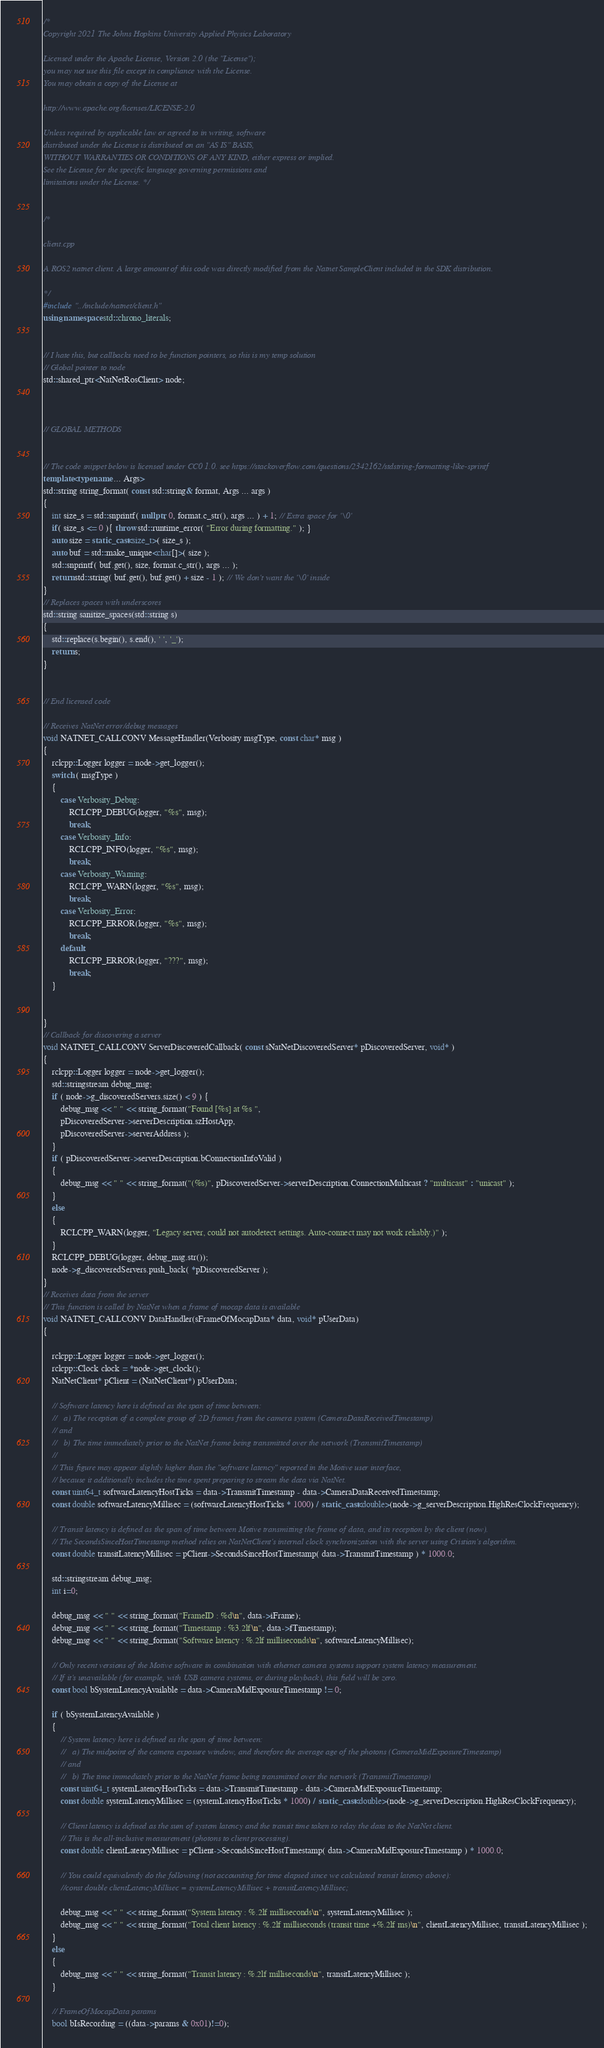Convert code to text. <code><loc_0><loc_0><loc_500><loc_500><_C++_>/* 
Copyright 2021 The Johns Hopkins University Applied Physics Laboratory

Licensed under the Apache License, Version 2.0 (the "License");
you may not use this file except in compliance with the License.
You may obtain a copy of the License at

http://www.apache.org/licenses/LICENSE-2.0

Unless required by applicable law or agreed to in writing, software
distributed under the License is distributed on an "AS IS" BASIS,
WITHOUT WARRANTIES OR CONDITIONS OF ANY KIND, either express or implied.
See the License for the specific language governing permissions and
limitations under the License. */


/*

client.cpp

A ROS2 natnet client. A large amount of this code was directly modified from the Natnet SampleClient included in the SDK distribution. 

*/
#include "../include/natnet/client.h"
using namespace std::chrono_literals;


// I hate this, but callbacks need to be function pointers, so this is my temp solution
// Global pointer to node
std::shared_ptr<NatNetRosClient> node;



// GLOBAL METHODS


// The code snippet below is licensed under CC0 1.0. see https://stackoverflow.com/questions/2342162/stdstring-formatting-like-sprintf
template<typename ... Args>
std::string string_format( const std::string& format, Args ... args )
{
    int size_s = std::snprintf( nullptr, 0, format.c_str(), args ... ) + 1; // Extra space for '\0'
    if( size_s <= 0 ){ throw std::runtime_error( "Error during formatting." ); }
    auto size = static_cast<size_t>( size_s );
    auto buf = std::make_unique<char[]>( size );
    std::snprintf( buf.get(), size, format.c_str(), args ... );
    return std::string( buf.get(), buf.get() + size - 1 ); // We don't want the '\0' inside
}
// Replaces spaces with underscores
std::string sanitize_spaces(std::string s)
{
    std::replace(s.begin(), s.end(), ' ', '_');
    return s;
}


// End licensed code

// Receives NatNet error/debug messages
void NATNET_CALLCONV MessageHandler(Verbosity msgType, const char* msg )
{
    rclcpp::Logger logger = node->get_logger();
    switch ( msgType )
    {
        case Verbosity_Debug:
            RCLCPP_DEBUG(logger, "%s", msg);
            break;
        case Verbosity_Info:
            RCLCPP_INFO(logger, "%s", msg);
            break;
        case Verbosity_Warning:
            RCLCPP_WARN(logger, "%s", msg);
            break;
        case Verbosity_Error:
            RCLCPP_ERROR(logger, "%s", msg);
            break;
        default:
            RCLCPP_ERROR(logger, "???", msg);
            break;
    }

    
}
// Callback for discovering a server
void NATNET_CALLCONV ServerDiscoveredCallback( const sNatNetDiscoveredServer* pDiscoveredServer, void* )
{
    rclcpp::Logger logger = node->get_logger();
    std::stringstream debug_msg;
    if ( node->g_discoveredServers.size() < 9 ) {
        debug_msg << " " << string_format("Found [%s] at %s ",
        pDiscoveredServer->serverDescription.szHostApp,
        pDiscoveredServer->serverAddress );
    }
    if ( pDiscoveredServer->serverDescription.bConnectionInfoValid )
    {
        debug_msg << " " << string_format("(%s)", pDiscoveredServer->serverDescription.ConnectionMulticast ? "multicast" : "unicast" );
    }
    else
    {
        RCLCPP_WARN(logger, "Legacy server, could not autodetect settings. Auto-connect may not work reliably.)" );
    }
    RCLCPP_DEBUG(logger, debug_msg.str());
    node->g_discoveredServers.push_back( *pDiscoveredServer );
}
// Receives data from the server
// This function is called by NatNet when a frame of mocap data is available
void NATNET_CALLCONV DataHandler(sFrameOfMocapData* data, void* pUserData)
{
    
    rclcpp::Logger logger = node->get_logger();
    rclcpp::Clock clock = *node->get_clock();
    NatNetClient* pClient = (NatNetClient*) pUserData;

    // Software latency here is defined as the span of time between:
    //   a) The reception of a complete group of 2D frames from the camera system (CameraDataReceivedTimestamp)
    // and
    //   b) The time immediately prior to the NatNet frame being transmitted over the network (TransmitTimestamp)
    //
    // This figure may appear slightly higher than the "software latency" reported in the Motive user interface,
    // because it additionally includes the time spent preparing to stream the data via NatNet.
    const uint64_t softwareLatencyHostTicks = data->TransmitTimestamp - data->CameraDataReceivedTimestamp;
    const double softwareLatencyMillisec = (softwareLatencyHostTicks * 1000) / static_cast<double>(node->g_serverDescription.HighResClockFrequency);

    // Transit latency is defined as the span of time between Motive transmitting the frame of data, and its reception by the client (now).
    // The SecondsSinceHostTimestamp method relies on NatNetClient's internal clock synchronization with the server using Cristian's algorithm.
    const double transitLatencyMillisec = pClient->SecondsSinceHostTimestamp( data->TransmitTimestamp ) * 1000.0;

    std::stringstream debug_msg;
    int i=0;

    debug_msg << " " << string_format("FrameID : %d\n", data->iFrame);
    debug_msg << " " << string_format("Timestamp : %3.2lf\n", data->fTimestamp);
    debug_msg << " " << string_format("Software latency : %.2lf milliseconds\n", softwareLatencyMillisec);

    // Only recent versions of the Motive software in combination with ethernet camera systems support system latency measurement.
    // If it's unavailable (for example, with USB camera systems, or during playback), this field will be zero.
    const bool bSystemLatencyAvailable = data->CameraMidExposureTimestamp != 0;

    if ( bSystemLatencyAvailable )
    {
        // System latency here is defined as the span of time between:
        //   a) The midpoint of the camera exposure window, and therefore the average age of the photons (CameraMidExposureTimestamp)
        // and
        //   b) The time immediately prior to the NatNet frame being transmitted over the network (TransmitTimestamp)
        const uint64_t systemLatencyHostTicks = data->TransmitTimestamp - data->CameraMidExposureTimestamp;
        const double systemLatencyMillisec = (systemLatencyHostTicks * 1000) / static_cast<double>(node->g_serverDescription.HighResClockFrequency);

        // Client latency is defined as the sum of system latency and the transit time taken to relay the data to the NatNet client.
        // This is the all-inclusive measurement (photons to client processing).
        const double clientLatencyMillisec = pClient->SecondsSinceHostTimestamp( data->CameraMidExposureTimestamp ) * 1000.0;

        // You could equivalently do the following (not accounting for time elapsed since we calculated transit latency above):
        //const double clientLatencyMillisec = systemLatencyMillisec + transitLatencyMillisec;

        debug_msg << " " << string_format("System latency : %.2lf milliseconds\n", systemLatencyMillisec );
        debug_msg << " " << string_format("Total client latency : %.2lf milliseconds (transit time +%.2lf ms)\n", clientLatencyMillisec, transitLatencyMillisec );
    }
    else
    {
        debug_msg << " " << string_format("Transit latency : %.2lf milliseconds\n", transitLatencyMillisec );
    }

    // FrameOfMocapData params
    bool bIsRecording = ((data->params & 0x01)!=0);</code> 